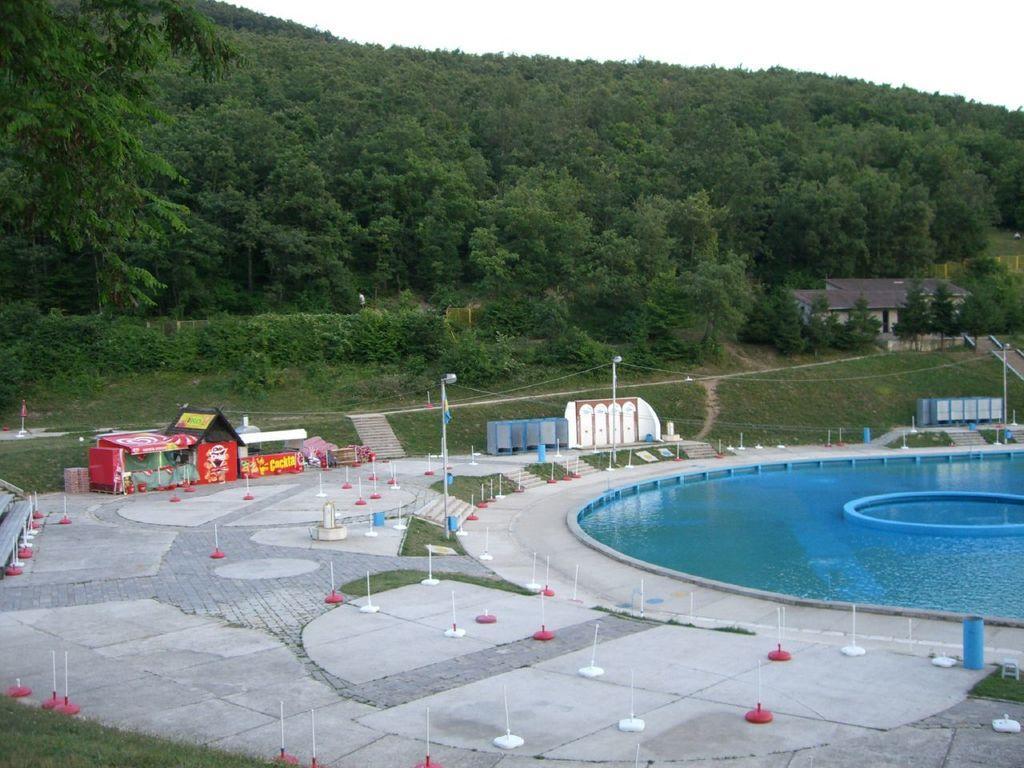Please provide a concise description of this image. In this image there is a big pool beside that there is a ground with some poles and also stall, also there are is a mountain with so many trees under that there is a building. 